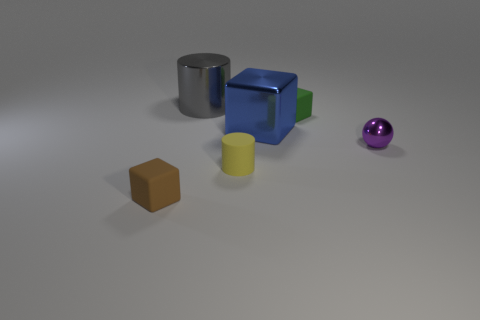How many objects are small rubber things that are in front of the tiny purple sphere or cylinders behind the tiny purple object?
Ensure brevity in your answer.  3. How many other objects are there of the same color as the big cylinder?
Give a very brief answer. 0. What material is the purple thing?
Give a very brief answer. Metal. Do the thing on the right side of the green matte object and the tiny brown thing have the same size?
Your response must be concise. Yes. What size is the other object that is the same shape as the big gray shiny thing?
Give a very brief answer. Small. Are there the same number of large metal cylinders behind the metallic cylinder and small matte things that are behind the yellow rubber cylinder?
Provide a succinct answer. No. What size is the rubber cube in front of the tiny green rubber cube?
Your response must be concise. Small. Is there anything else that is the same shape as the small purple thing?
Make the answer very short. No. Are there the same number of metal cubes that are on the left side of the small matte cylinder and tiny gray balls?
Ensure brevity in your answer.  Yes. There is a large blue object; are there any big blue objects behind it?
Ensure brevity in your answer.  No. 